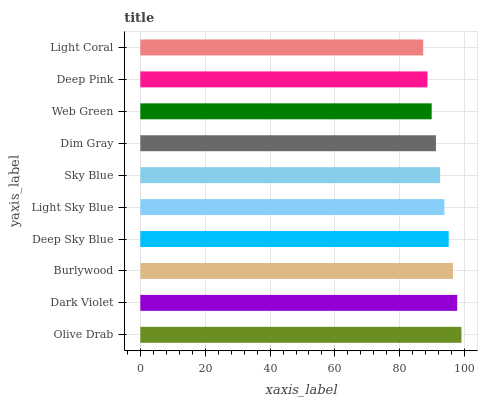Is Light Coral the minimum?
Answer yes or no. Yes. Is Olive Drab the maximum?
Answer yes or no. Yes. Is Dark Violet the minimum?
Answer yes or no. No. Is Dark Violet the maximum?
Answer yes or no. No. Is Olive Drab greater than Dark Violet?
Answer yes or no. Yes. Is Dark Violet less than Olive Drab?
Answer yes or no. Yes. Is Dark Violet greater than Olive Drab?
Answer yes or no. No. Is Olive Drab less than Dark Violet?
Answer yes or no. No. Is Light Sky Blue the high median?
Answer yes or no. Yes. Is Sky Blue the low median?
Answer yes or no. Yes. Is Light Coral the high median?
Answer yes or no. No. Is Dark Violet the low median?
Answer yes or no. No. 